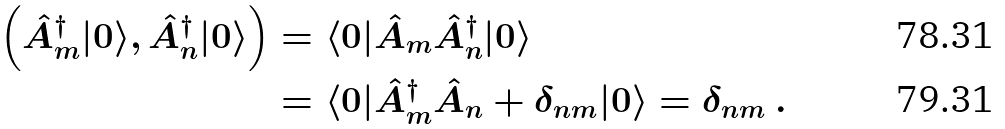Convert formula to latex. <formula><loc_0><loc_0><loc_500><loc_500>\left ( \hat { A } ^ { \dagger } _ { m } | 0 \rangle , \hat { A } ^ { \dagger } _ { n } | 0 \rangle \right ) & = \langle 0 | \hat { A } _ { m } \hat { A } ^ { \dagger } _ { n } | 0 \rangle \\ & = \langle 0 | \hat { A } _ { m } ^ { \dagger } \hat { A } _ { n } + \delta _ { n m } | 0 \rangle = \delta _ { n m } \ .</formula> 